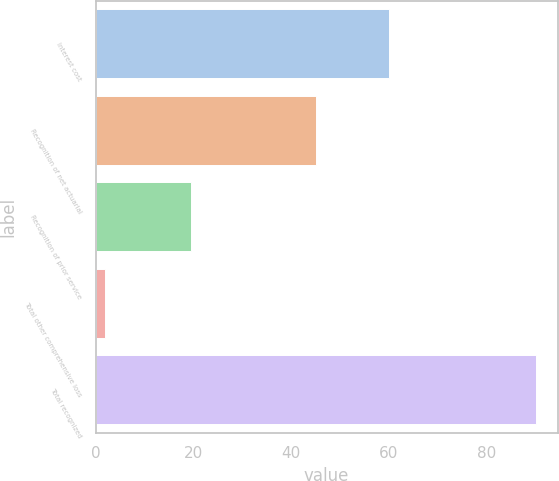Convert chart to OTSL. <chart><loc_0><loc_0><loc_500><loc_500><bar_chart><fcel>Interest cost<fcel>Recognition of net actuarial<fcel>Recognition of prior service<fcel>Total other comprehensive loss<fcel>Total recognized<nl><fcel>60<fcel>45<fcel>19.6<fcel>2<fcel>90<nl></chart> 